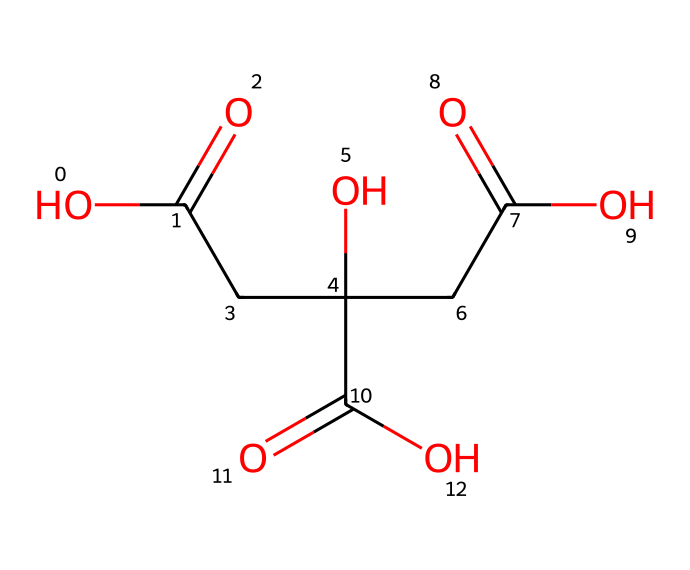What is the total number of carbon atoms in this molecule? The SMILES structure represents a compound with four carbon atoms (C). Each occurrence of "C" in the SMILES indicates a carbon atom directly contributing to the molecular structure, and by counting them, we find there are four.
Answer: 4 How many functional groups are present in this acid? By analyzing the SMILES representation, we can identify multiple functional groups including carboxylic acids (–COOH) which are prominent in this structure. There are three carboxylic acid functional groups (noted as C(=O)O in the SMILES), indicating there are three such groups present.
Answer: 3 What type of acid is represented by this chemical structure? The presence of multiple carboxylic acid groups (–COOH) indicates that this compound is a polycarboxylic acid. These acids contain more than one carboxylic acid group, emphasizing their acidic properties.
Answer: polycarboxylic acid Which atoms in the structure contribute to its acidic properties? The acidic properties of this compound are attributed to the carboxylic acid functional groups (–COOH). These groups can donate protons (H+) in solution, which is characteristic of acids. Upon locating the carboxyl groups in the structure, we can confirm their contribution to acidity.
Answer: carboxylic acid groups What is the role of acids in sports drinks? Acids in sports drinks, such as citric acid and phosphoric acid, serve to improve taste and play a role in maintaining electrolyte balance in the body, assisting in hydration, and enhancing the absorption of carbohydrates during exercise.
Answer: enhance hydration 